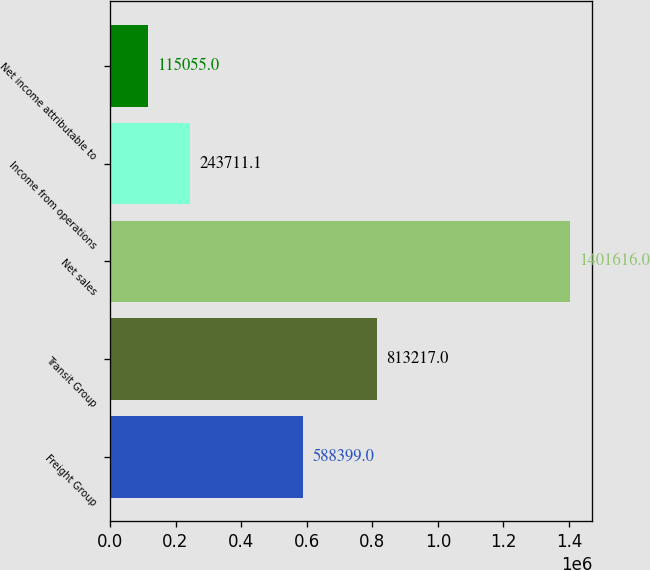Convert chart. <chart><loc_0><loc_0><loc_500><loc_500><bar_chart><fcel>Freight Group<fcel>Transit Group<fcel>Net sales<fcel>Income from operations<fcel>Net income attributable to<nl><fcel>588399<fcel>813217<fcel>1.40162e+06<fcel>243711<fcel>115055<nl></chart> 